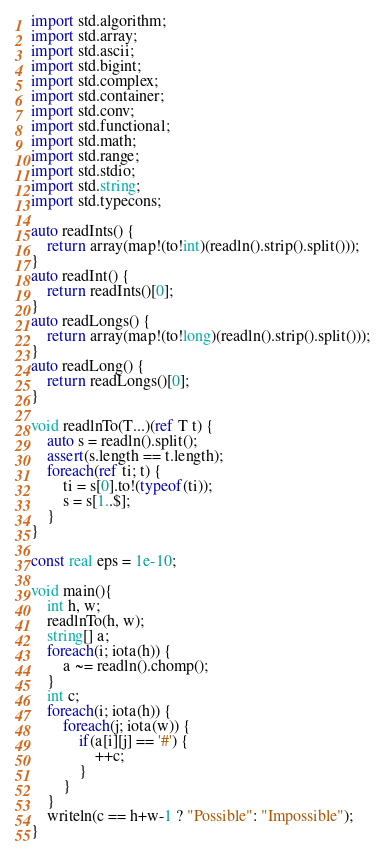Convert code to text. <code><loc_0><loc_0><loc_500><loc_500><_D_>import std.algorithm;
import std.array;
import std.ascii;
import std.bigint;
import std.complex;
import std.container;
import std.conv;
import std.functional;
import std.math;
import std.range;
import std.stdio;
import std.string;
import std.typecons;

auto readInts() {
	return array(map!(to!int)(readln().strip().split()));
}
auto readInt() {
	return readInts()[0];
}
auto readLongs() {
	return array(map!(to!long)(readln().strip().split()));
}
auto readLong() {
	return readLongs()[0];
}

void readlnTo(T...)(ref T t) {
    auto s = readln().split();
    assert(s.length == t.length);
    foreach(ref ti; t) {
        ti = s[0].to!(typeof(ti));
        s = s[1..$];
    }
}

const real eps = 1e-10;

void main(){
    int h, w;
    readlnTo(h, w);
    string[] a;
    foreach(i; iota(h)) {
        a ~= readln().chomp();
    }
    int c;
    foreach(i; iota(h)) {
        foreach(j; iota(w)) {
            if(a[i][j] == '#') {
                ++c;
            }
        }
    }
    writeln(c == h+w-1 ? "Possible": "Impossible");
}

</code> 